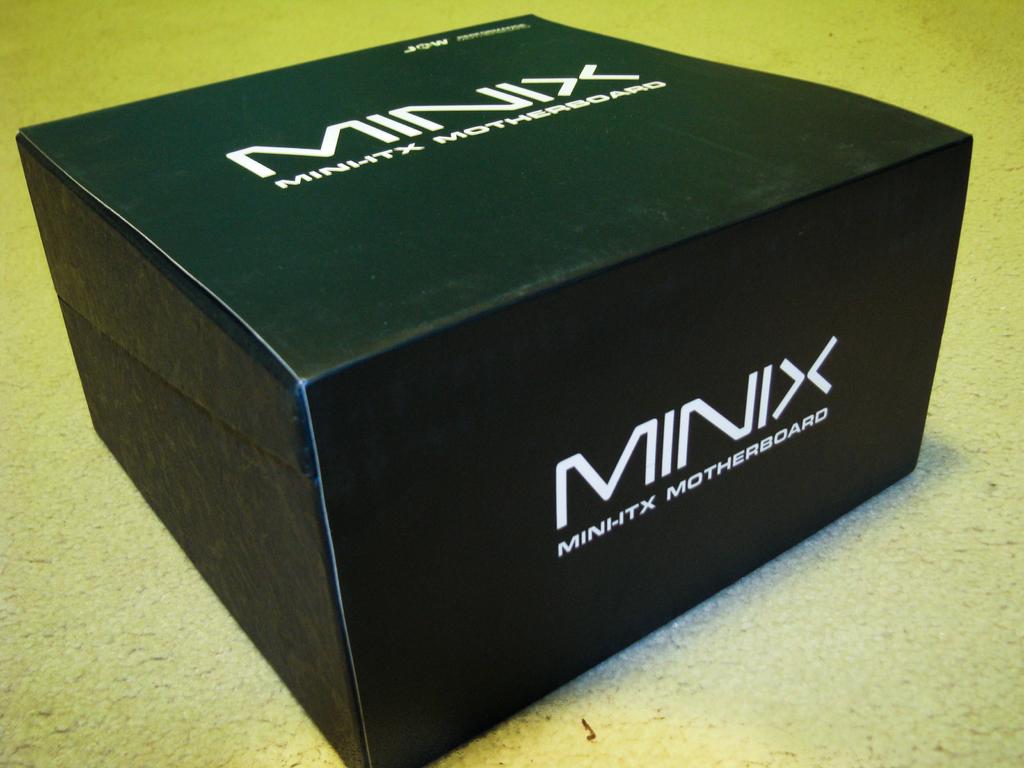What is in the box?
Provide a short and direct response. Motherboard. What company makes this motherboard?
Make the answer very short. Minix. 